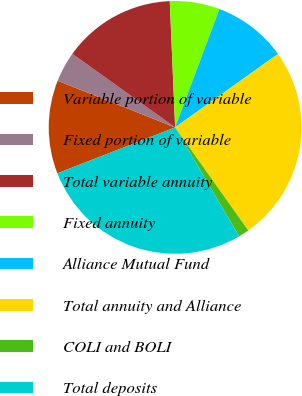<chart> <loc_0><loc_0><loc_500><loc_500><pie_chart><fcel>Variable portion of variable<fcel>Fixed portion of variable<fcel>Total variable annuity<fcel>Fixed annuity<fcel>Alliance Mutual Fund<fcel>Total annuity and Alliance<fcel>COLI and BOLI<fcel>Total deposits<nl><fcel>11.93%<fcel>3.87%<fcel>14.44%<fcel>6.38%<fcel>9.43%<fcel>25.04%<fcel>1.37%<fcel>27.54%<nl></chart> 